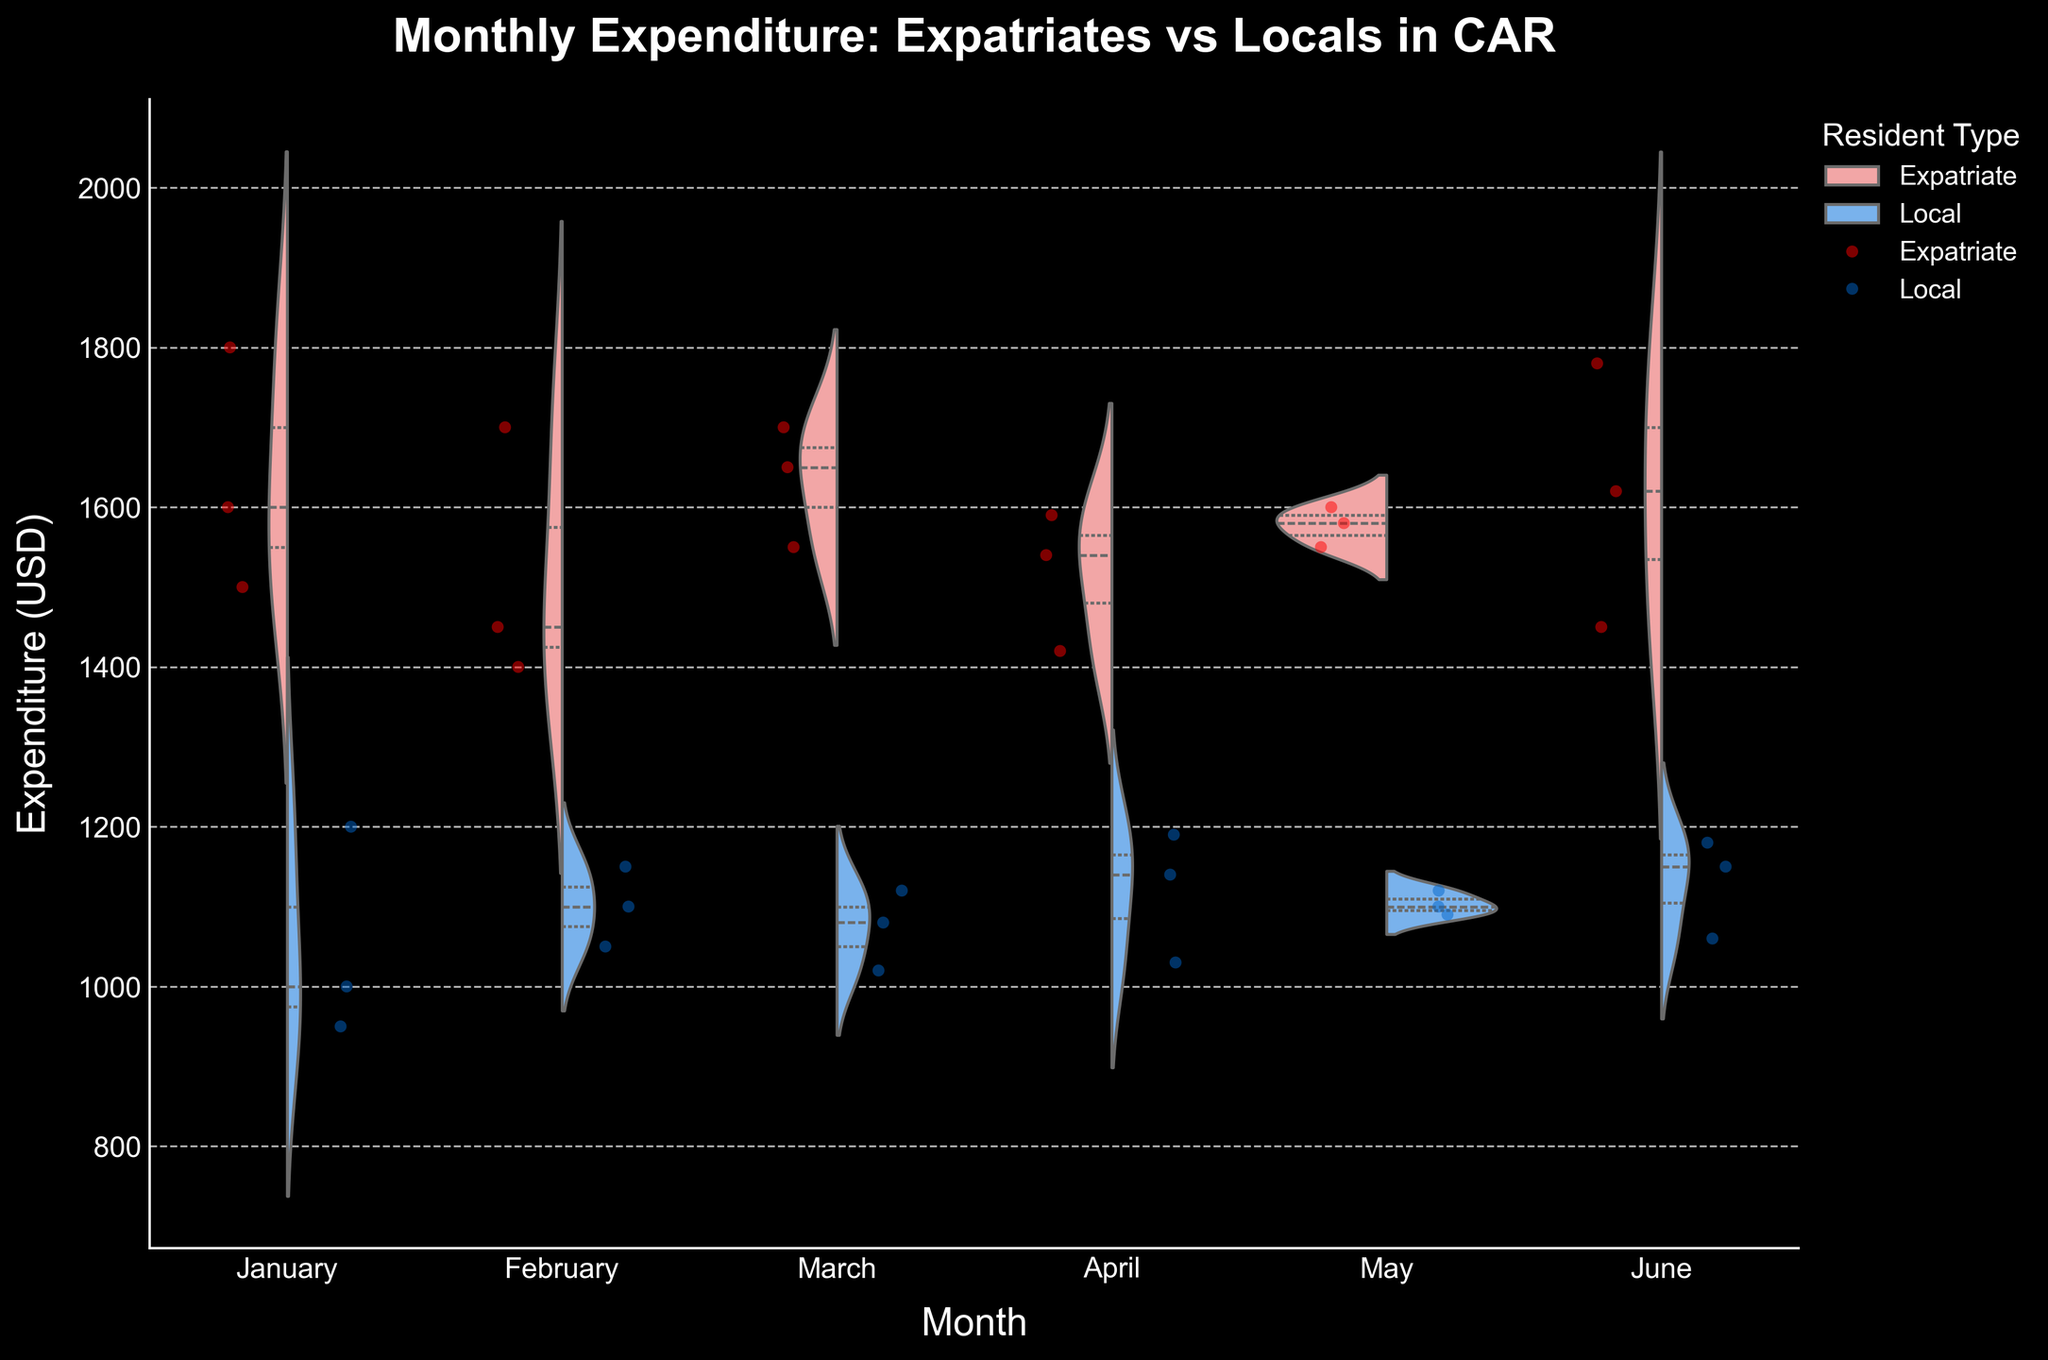What is the title of the plot? The title is usually located at the top of the plot. It provides the main context of what the plot represents. In this case, it's visible at the top and it reads "Monthly Expenditure: Expatriates vs Locals in CAR."
Answer: Monthly Expenditure: Expatriates vs Locals in CAR Which months have the highest variability in expenditures for expatriates? Variability in expenditures can be observed by looking at the width of the violin plots. The wider the plot, the higher the variability. Here, it appears that June shows a considerable width variance in the expenditures of expatriates.
Answer: June What are the color representations for expatriates and locals in the plot? The colors used in the violin plot and jittered points distinctly identify expatriates and locals. Expatriates are represented by shades of red (violin plot in pinkish-red and points in red), while locals are represented by shades of blue (violin plot in blue and points in dark blue).
Answer: Red for expatriates, blue for locals What is the range of expenditures for locals in January? The range can be determined by observing the extent of the violin plot on the vertical axis for locals in January. The lowest point is around 950 and the highest is around 1200.
Answer: 950 to 1200 Compare the median expenditures between expatriates and locals in March. The median expenditures can be discerned from the white dot inside the violin plot. For expatriates in March, the median is around 1650, while for locals it is around 1080.
Answer: Expatriates: 1650, Locals: 1080 Which month has the smallest difference in expenditures between expatriates and locals? To find the smallest difference, we look at the overlap between the two violin plots. It seems that in April, the expenditures of the two groups are closest to each other on the vertical axis.
Answer: April Is there any month where the median expenditure of locals is higher than the lowest expenditure of expatriates? By examining the positions of the median for locals and the lowest points for expatriates across all months, it shows that in February, the lowest expenditure for expatriates (around 1400) is higher than the median expenditure (around 1100) of locals.
Answer: No What insights can be derived about the variability of expenditures for expats compared to locals across the months? Expatriates show consistently higher variability in expenditures compared to locals, as observed from wider violin plots each month. This indicates a broader distribution and greater spending differences among expatriates.
Answer: Higher variability for expatriates In which month do locals have the highest mean expenditure? The mean expenditure can be inferred from the position and spread of the violin plot. For locals, the mean seems highest in April, as the violin plot extends higher than in other months.
Answer: April 